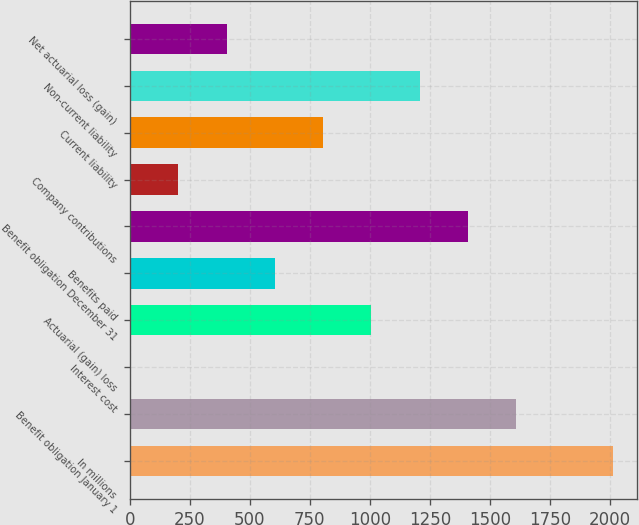<chart> <loc_0><loc_0><loc_500><loc_500><bar_chart><fcel>In millions<fcel>Benefit obligation January 1<fcel>Interest cost<fcel>Actuarial (gain) loss<fcel>Benefits paid<fcel>Benefit obligation December 31<fcel>Company contributions<fcel>Current liability<fcel>Non-current liability<fcel>Net actuarial loss (gain)<nl><fcel>2012<fcel>1609.8<fcel>1<fcel>1006.5<fcel>604.3<fcel>1408.7<fcel>202.1<fcel>805.4<fcel>1207.6<fcel>403.2<nl></chart> 